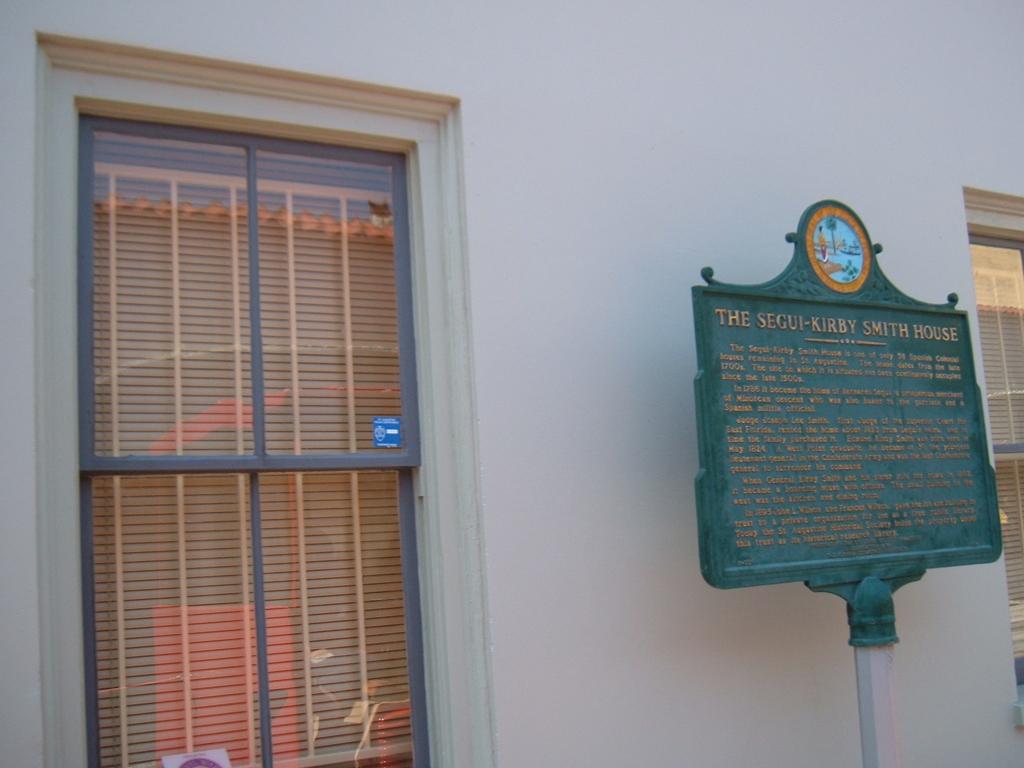What does the sign say?
Your response must be concise. The segui-kirby smith house. 